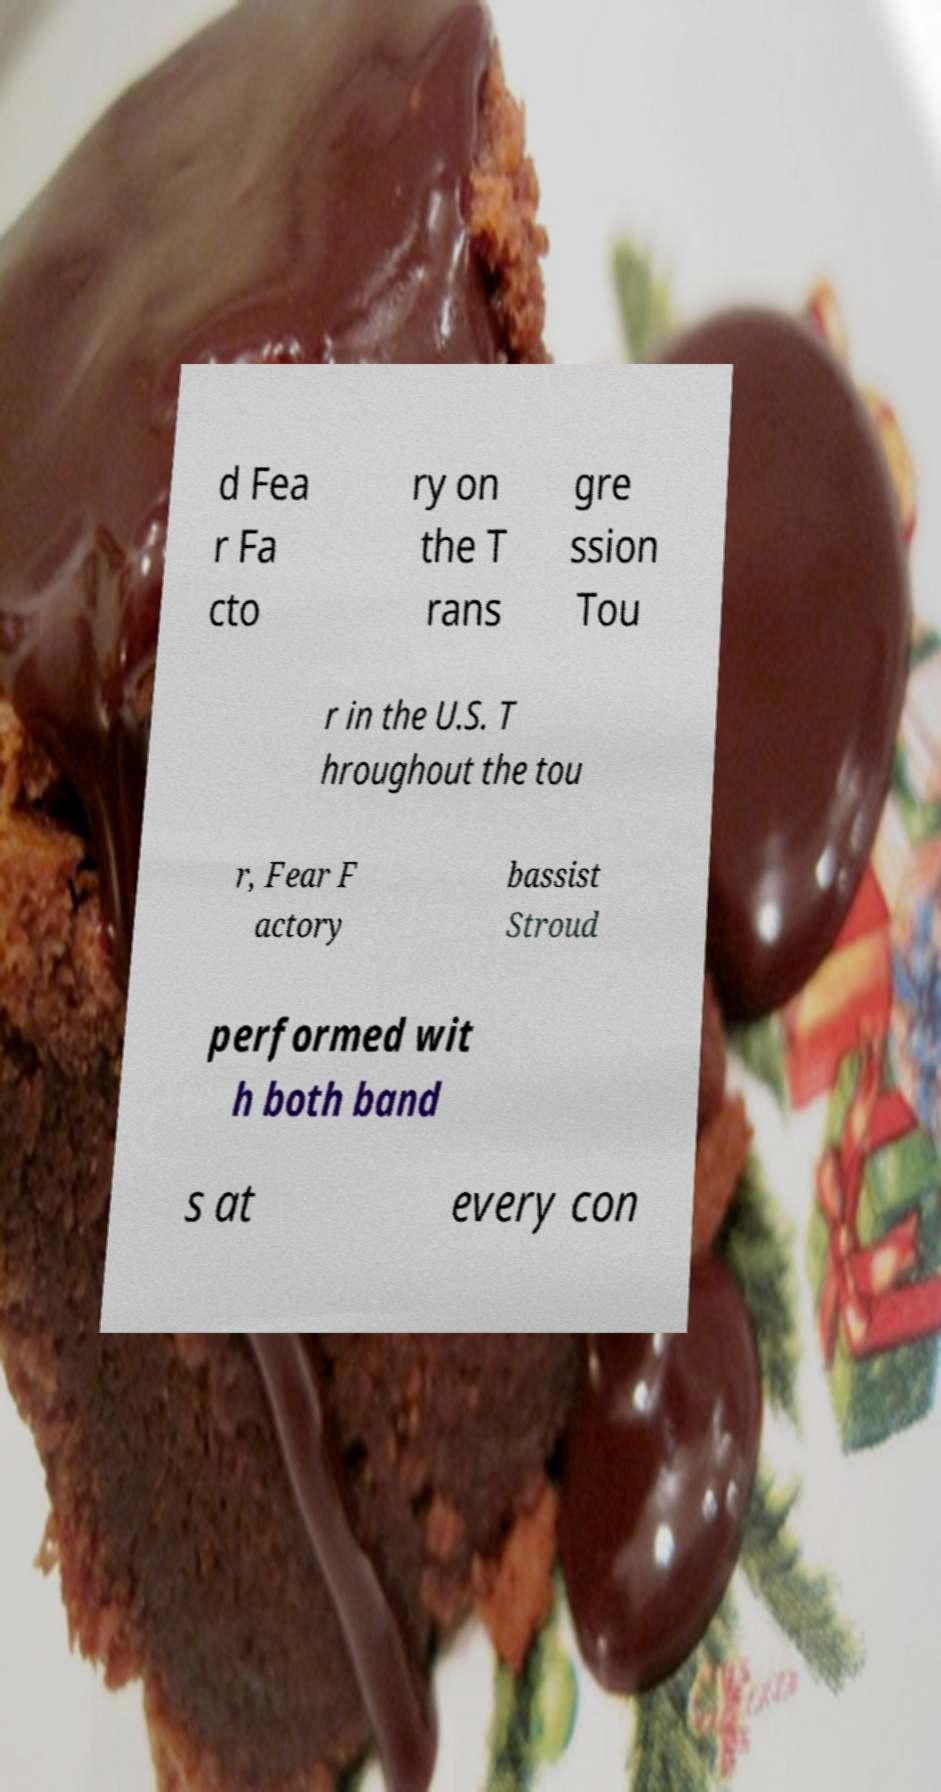Please identify and transcribe the text found in this image. d Fea r Fa cto ry on the T rans gre ssion Tou r in the U.S. T hroughout the tou r, Fear F actory bassist Stroud performed wit h both band s at every con 